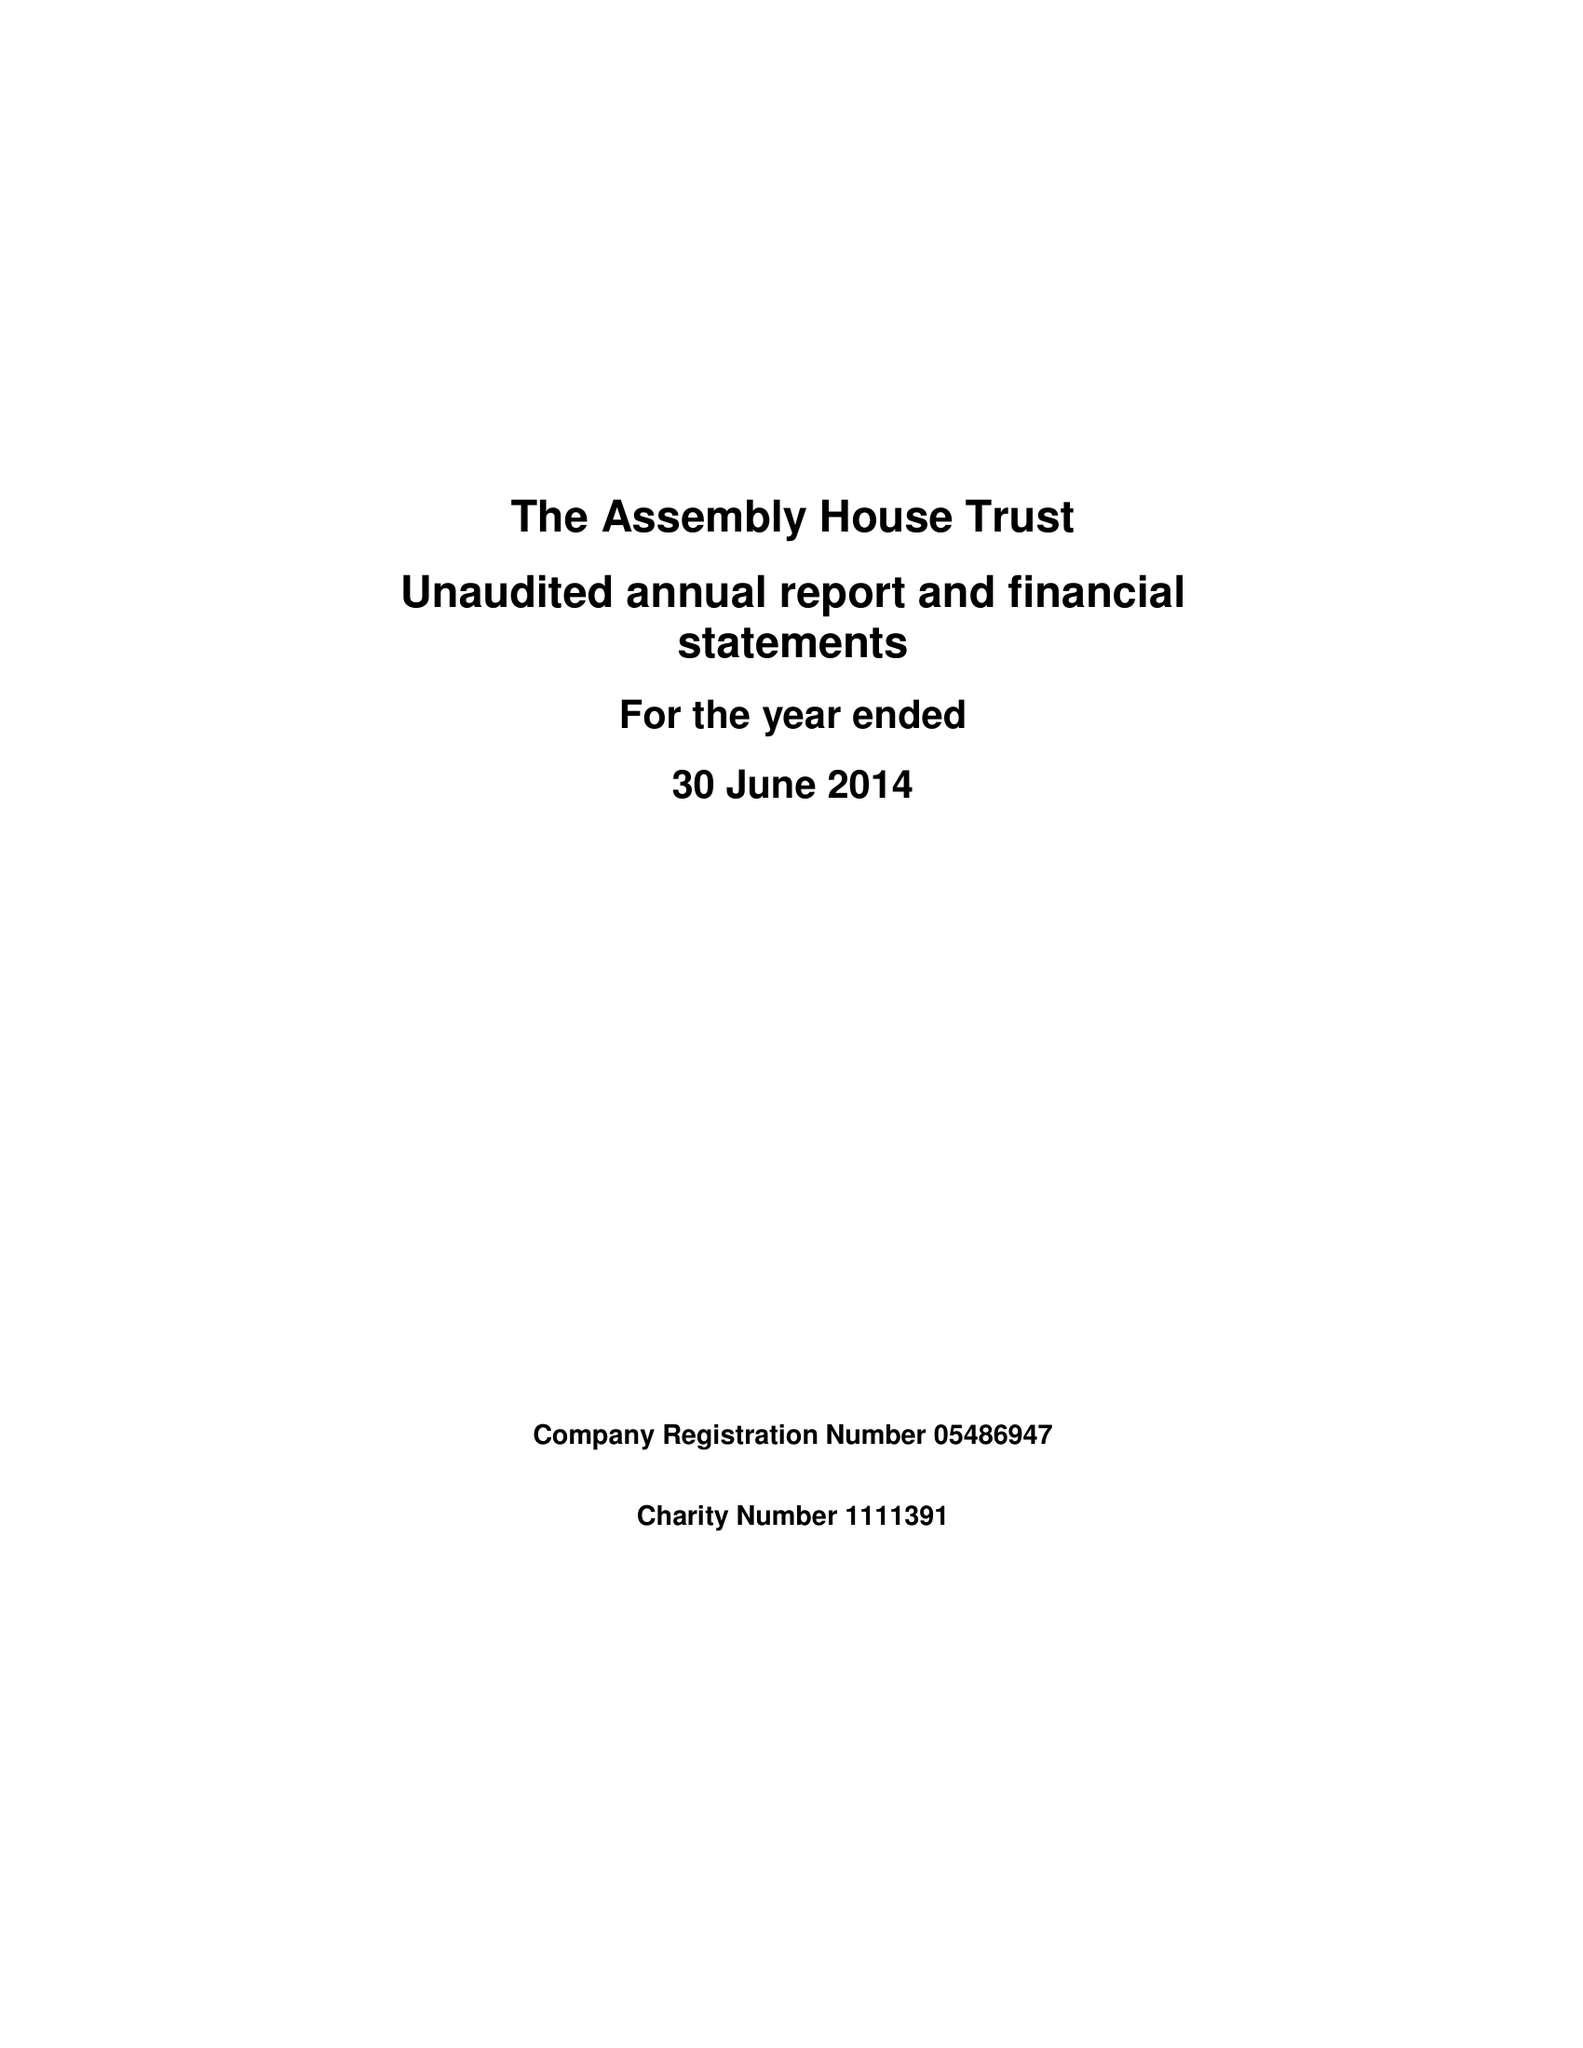What is the value for the report_date?
Answer the question using a single word or phrase. 2014-06-30 